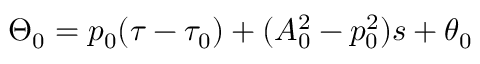Convert formula to latex. <formula><loc_0><loc_0><loc_500><loc_500>\Theta _ { 0 } = p _ { 0 } ( \tau - \tau _ { 0 } ) + ( A _ { 0 } ^ { 2 } - p _ { 0 } ^ { 2 } ) s + \theta _ { 0 }</formula> 